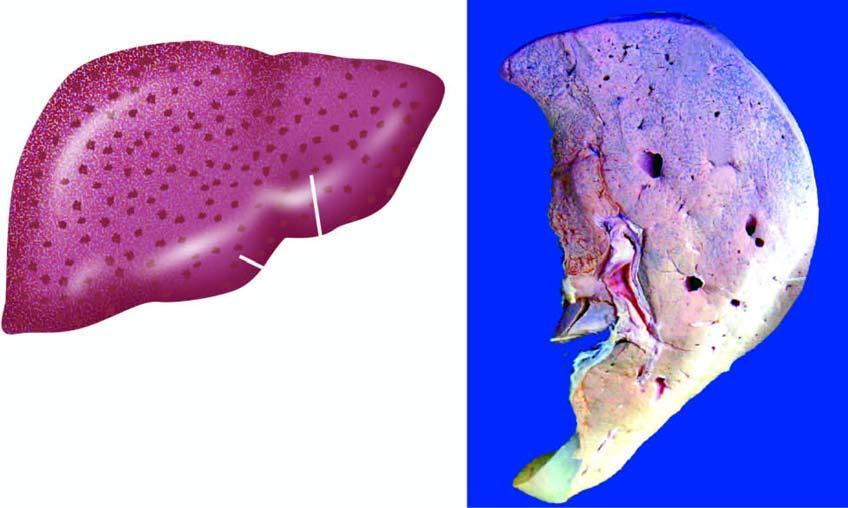does sectioned slice of the liver show mottled appearance-alternate pattern of dark congestion and pale fatty change?
Answer the question using a single word or phrase. No 